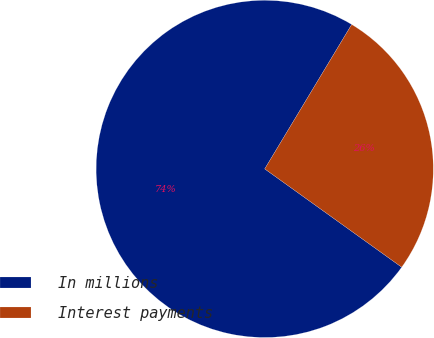<chart> <loc_0><loc_0><loc_500><loc_500><pie_chart><fcel>In millions<fcel>Interest payments<nl><fcel>73.72%<fcel>26.28%<nl></chart> 